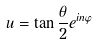<formula> <loc_0><loc_0><loc_500><loc_500>u = \tan \frac { \theta } { 2 } e ^ { i n \varphi }</formula> 